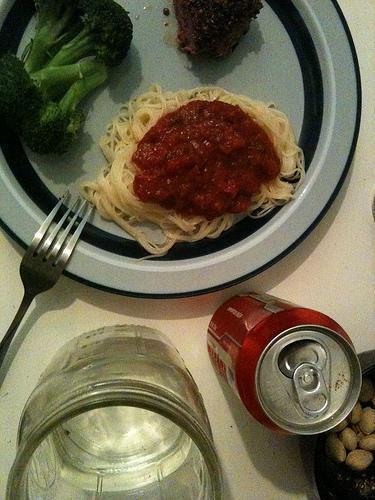How many plates?
Give a very brief answer. 1. 